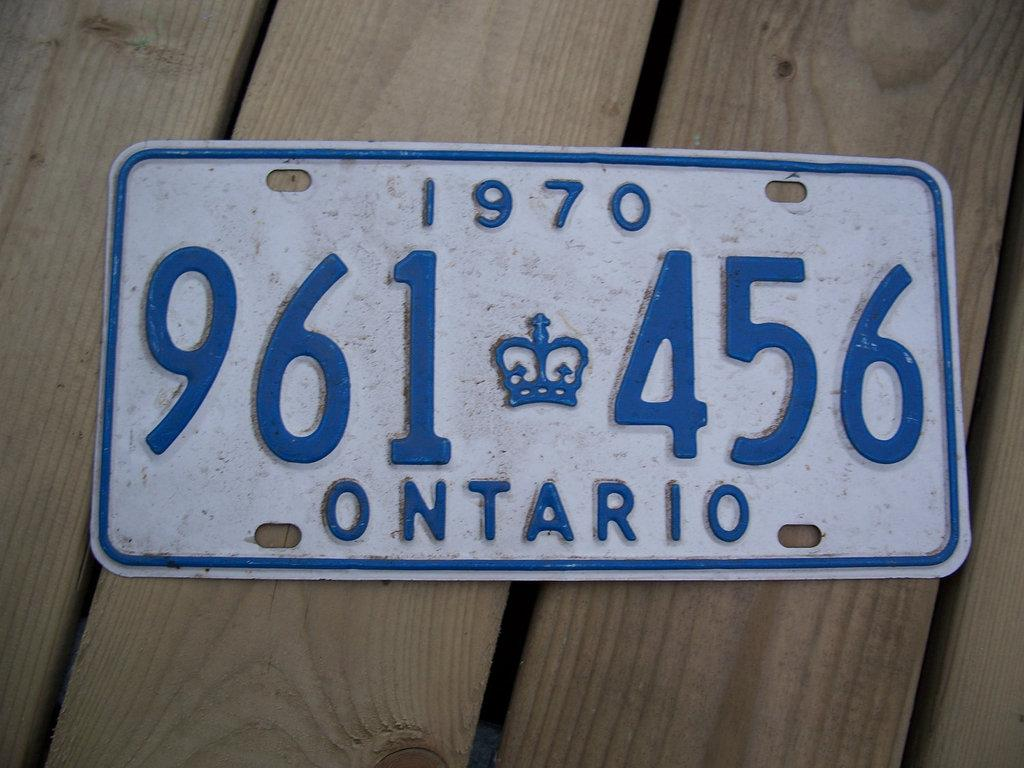Provide a one-sentence caption for the provided image. An older looking blue and white license plate that reads 1970 on the top, 961 456 in the middle and Ontario on the bottom. 